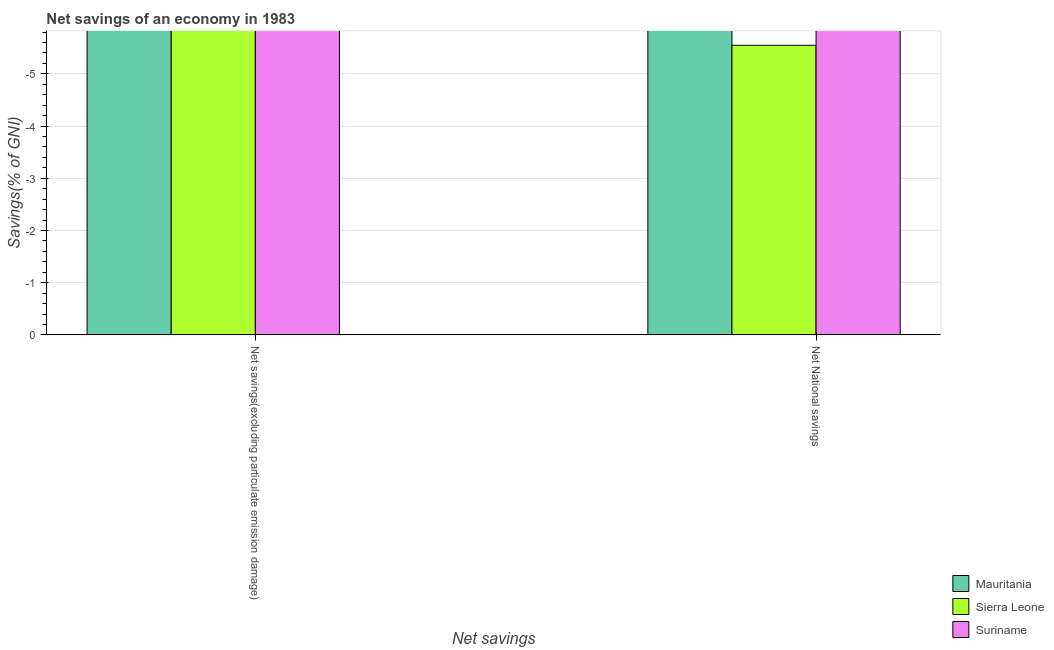How many bars are there on the 1st tick from the left?
Ensure brevity in your answer.  0. What is the label of the 1st group of bars from the left?
Your answer should be very brief. Net savings(excluding particulate emission damage). Across all countries, what is the minimum net savings(excluding particulate emission damage)?
Keep it short and to the point. 0. What is the total net savings(excluding particulate emission damage) in the graph?
Ensure brevity in your answer.  0. In how many countries, is the net national savings greater than the average net national savings taken over all countries?
Your answer should be compact. 0. Are all the bars in the graph horizontal?
Your answer should be compact. No. What is the difference between two consecutive major ticks on the Y-axis?
Make the answer very short. 1. Are the values on the major ticks of Y-axis written in scientific E-notation?
Provide a succinct answer. No. Does the graph contain grids?
Give a very brief answer. Yes. Where does the legend appear in the graph?
Provide a succinct answer. Bottom right. How are the legend labels stacked?
Offer a terse response. Vertical. What is the title of the graph?
Your answer should be very brief. Net savings of an economy in 1983. What is the label or title of the X-axis?
Your answer should be compact. Net savings. What is the label or title of the Y-axis?
Provide a succinct answer. Savings(% of GNI). What is the Savings(% of GNI) of Sierra Leone in Net savings(excluding particulate emission damage)?
Provide a succinct answer. 0. What is the Savings(% of GNI) in Suriname in Net savings(excluding particulate emission damage)?
Offer a terse response. 0. What is the Savings(% of GNI) of Sierra Leone in Net National savings?
Provide a succinct answer. 0. What is the average Savings(% of GNI) of Suriname per Net savings?
Provide a succinct answer. 0. 